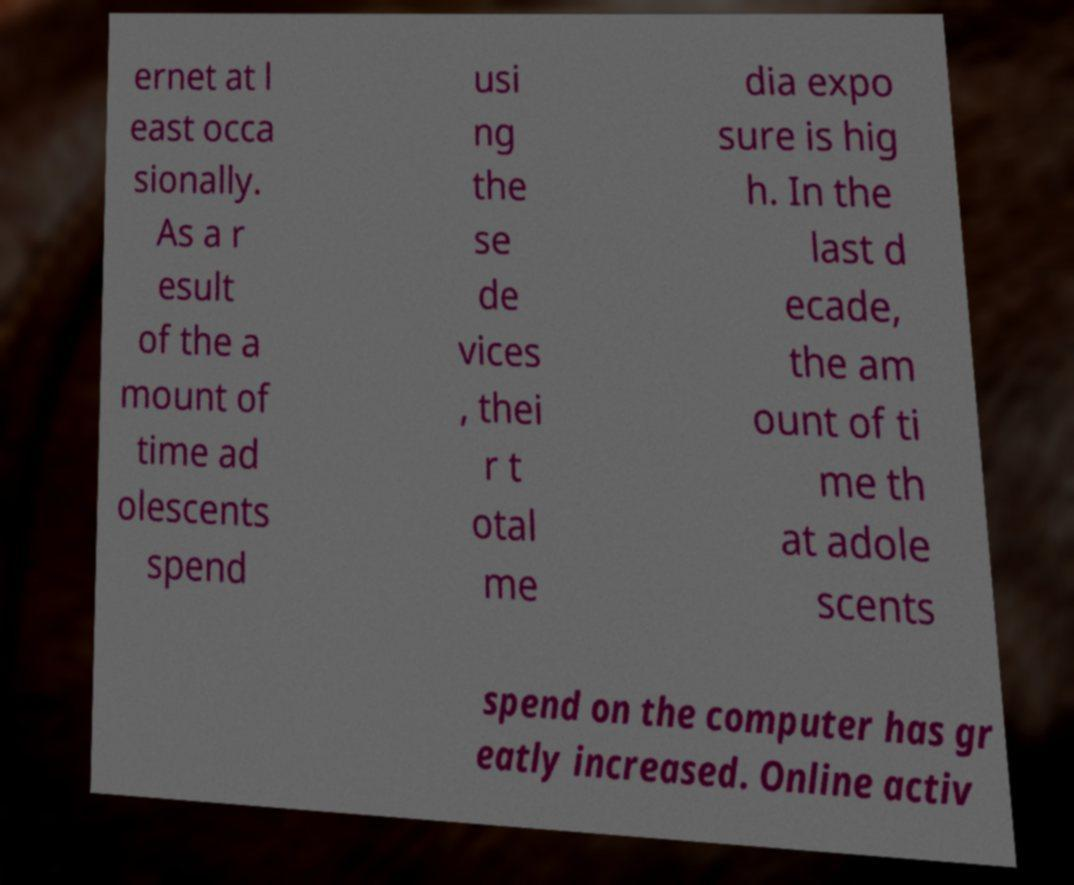Could you extract and type out the text from this image? ernet at l east occa sionally. As a r esult of the a mount of time ad olescents spend usi ng the se de vices , thei r t otal me dia expo sure is hig h. In the last d ecade, the am ount of ti me th at adole scents spend on the computer has gr eatly increased. Online activ 